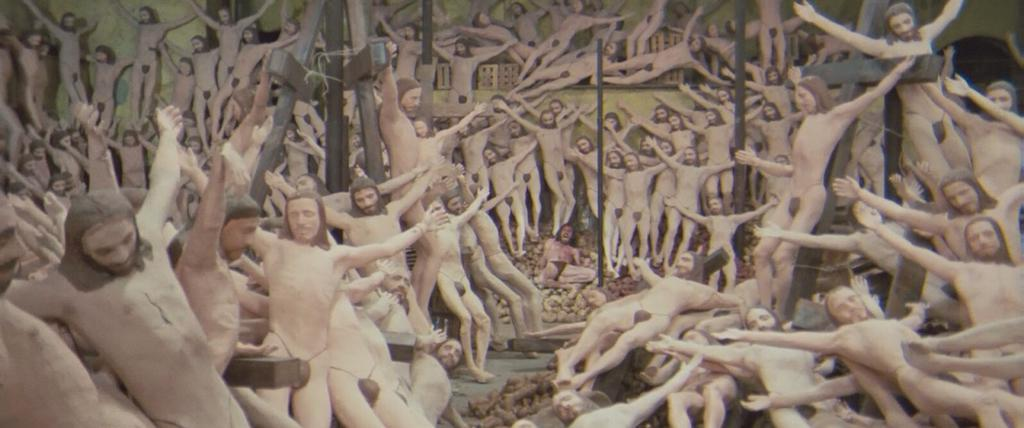What type of figures can be seen in the image? There are dolls in the image. What is the shape of the dolls? The dolls are in the shape of men. Are the dolls dressed in any clothing? No, the dolls are without clothes. How many legs can be seen on the moon in the image? There is no moon present in the image, and therefore no legs can be seen on it. 